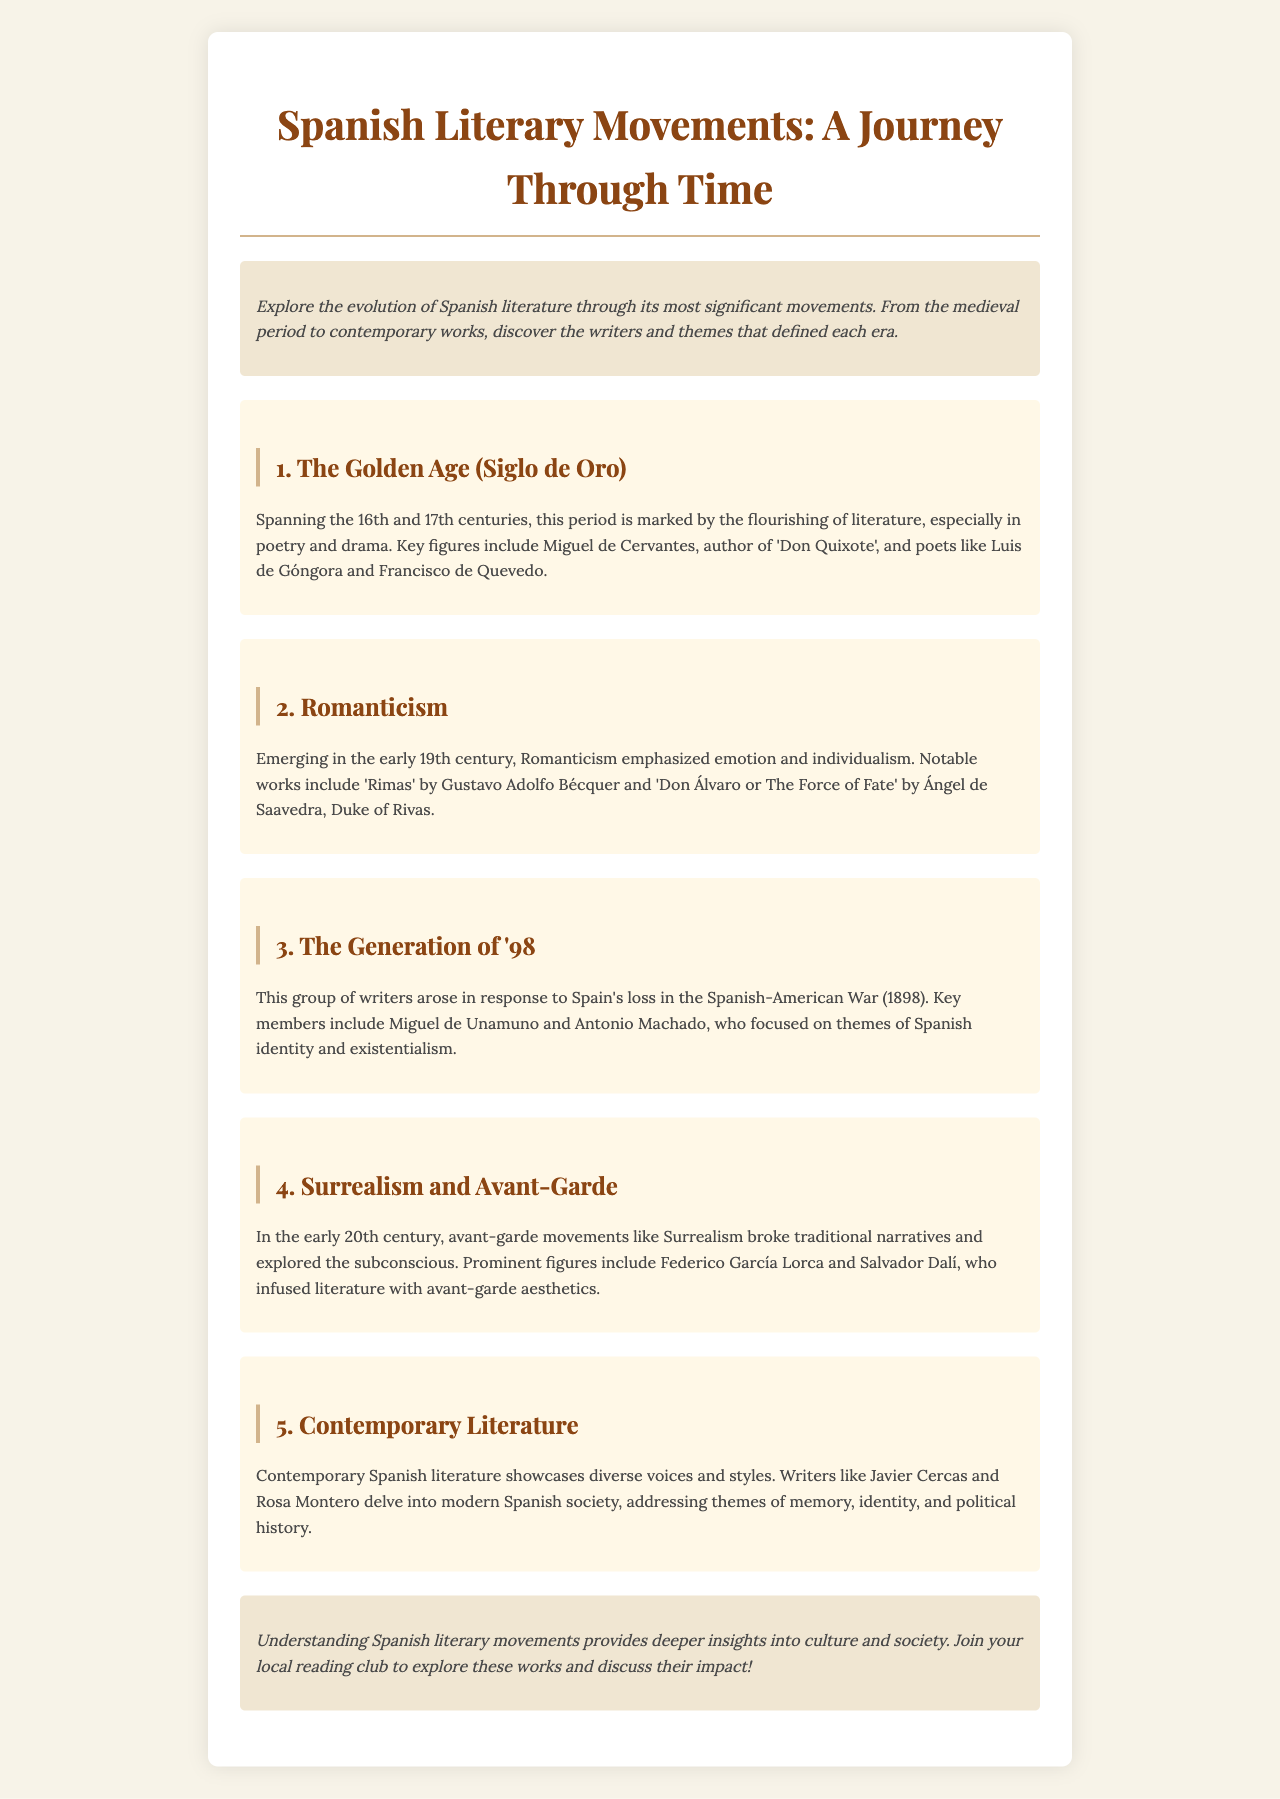What is the title of the brochure? The title of the brochure is mentioned at the top of the document.
Answer: Spanish Literary Movements: A Journey Through Time Who is the author of 'Don Quixote'? The author of 'Don Quixote' is specified in the section about the Golden Age.
Answer: Miguel de Cervantes Which literary movement emphasized emotion and individualism? The document states which movements focused on specific themes; this question refers to Romanticism.
Answer: Romanticism What period does the Golden Age cover? The Golden Age spans a specific period mentioned in the document.
Answer: 16th and 17th centuries Name one prominent figure of Surrealism. The document lists key figures associated with Surrealism in the early 20th century.
Answer: Federico García Lorca Which event led to the formation of the Generation of '98? The Generation of '98 arose due to a significant historical event referenced in the document.
Answer: Spanish-American War What are two themes addressed in contemporary literature? The document lists themes discussed by contemporary writers.
Answer: Memory, identity In which section is the concept of existentialism mentioned? Existentialism is discussed within a specific group of writers in the brochure.
Answer: The Generation of '98 What do the introductory and concluding sections have in common? Both the introduction and conclusion focus on the exploration of literary movements and their wider impact.
Answer: Cultural insights 